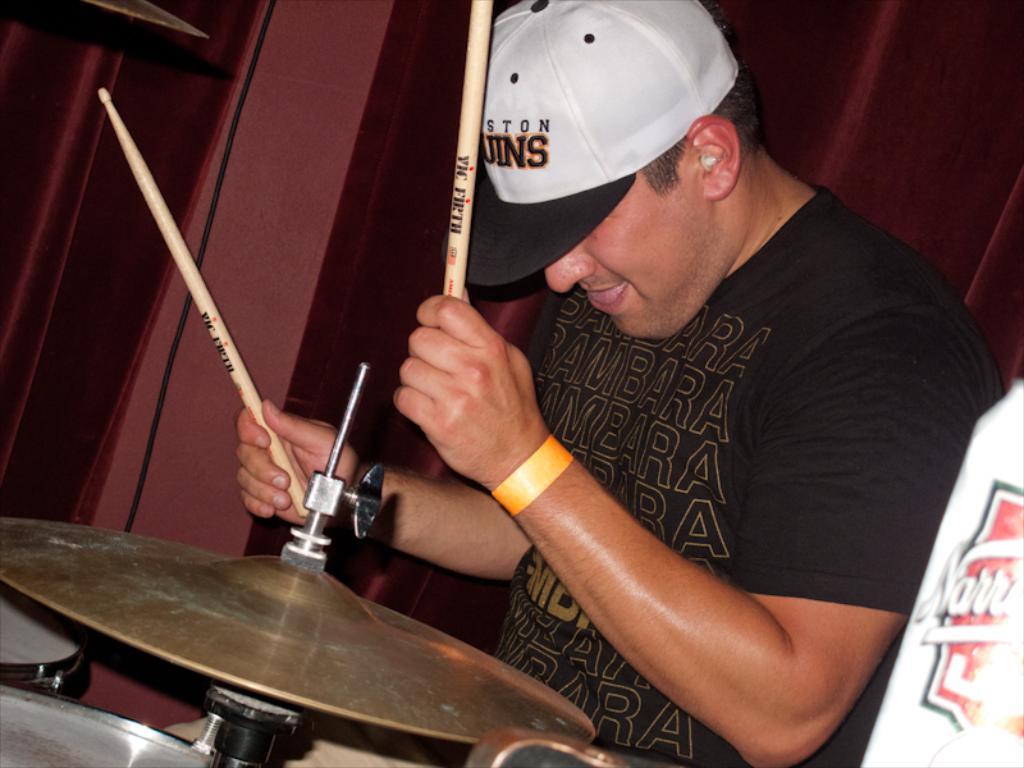What drummer is on the drum stick?
Provide a succinct answer. Vic firth. 